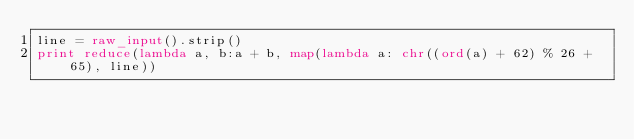Convert code to text. <code><loc_0><loc_0><loc_500><loc_500><_Python_>line = raw_input().strip()
print reduce(lambda a, b:a + b, map(lambda a: chr((ord(a) + 62) % 26 + 65), line))</code> 